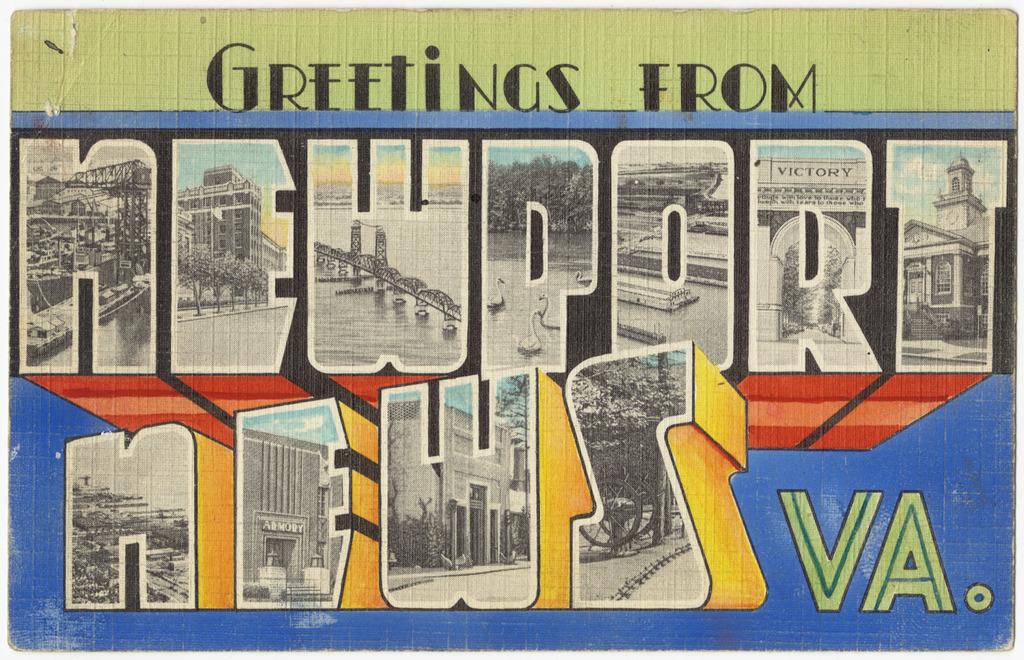What news company is mentioned?
Make the answer very short. Newport news. What city is the company from?
Provide a short and direct response. Newport news. 